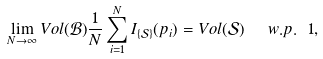Convert formula to latex. <formula><loc_0><loc_0><loc_500><loc_500>\lim _ { N \rightarrow \infty } V o l ( \mathcal { B } ) \frac { 1 } { N } \sum _ { i = 1 } ^ { N } I _ { \{ \mathcal { S } \} } ( p _ { i } ) = V o l ( \mathcal { S } ) \ \ w . p . \ 1 ,</formula> 